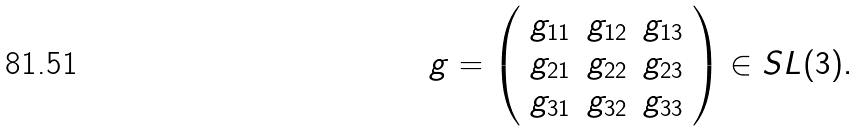Convert formula to latex. <formula><loc_0><loc_0><loc_500><loc_500>g = \left ( \begin{array} { c c c } g _ { 1 1 } & g _ { 1 2 } & g _ { 1 3 } \\ g _ { 2 1 } & g _ { 2 2 } & g _ { 2 3 } \\ g _ { 3 1 } & g _ { 3 2 } & g _ { 3 3 } \\ \end{array} \right ) \in S L ( 3 ) .</formula> 